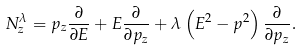Convert formula to latex. <formula><loc_0><loc_0><loc_500><loc_500>N _ { z } ^ { \lambda } = p _ { z } { \frac { \partial } { \partial E } } + E { \frac { \partial } { \partial p _ { z } } } + \lambda \left ( E ^ { 2 } - p ^ { 2 } \right ) { \frac { \partial } { \partial p _ { z } } } .</formula> 